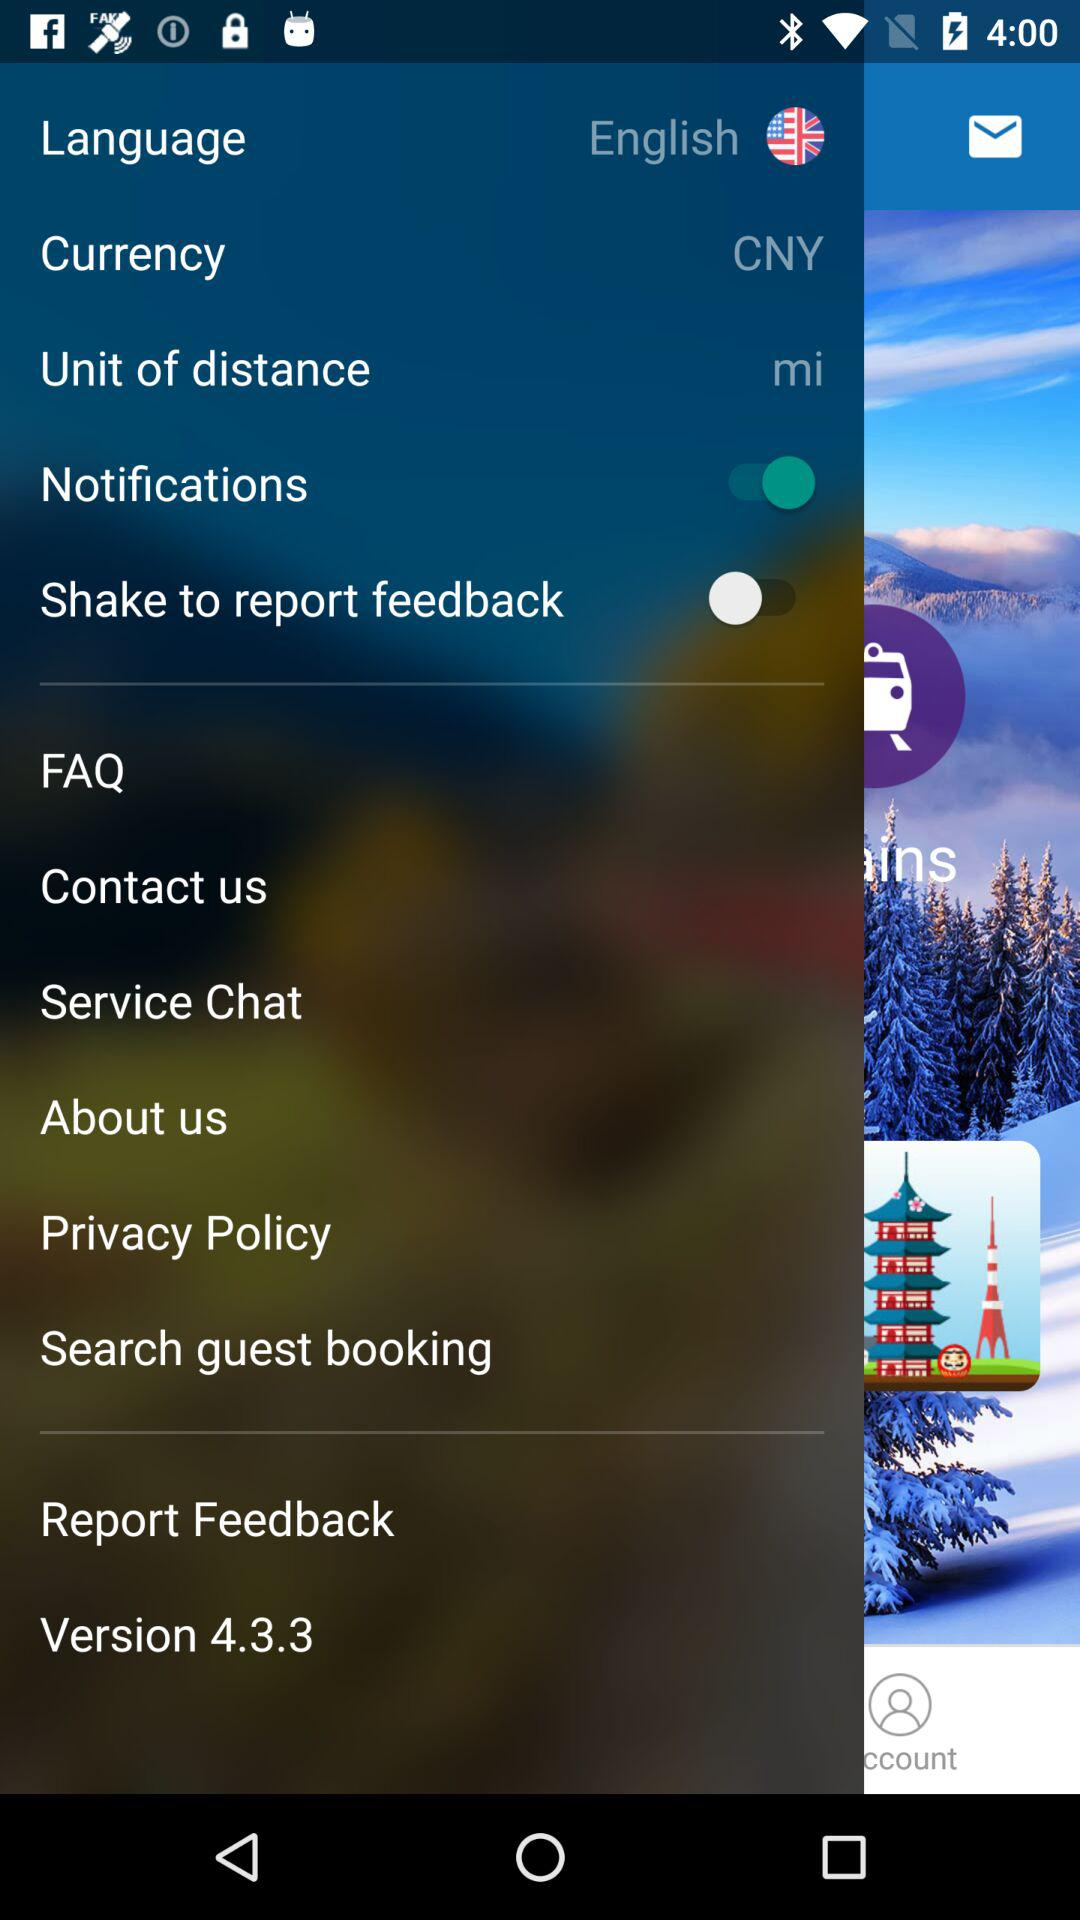What is the version? The version is 4.3.3. 